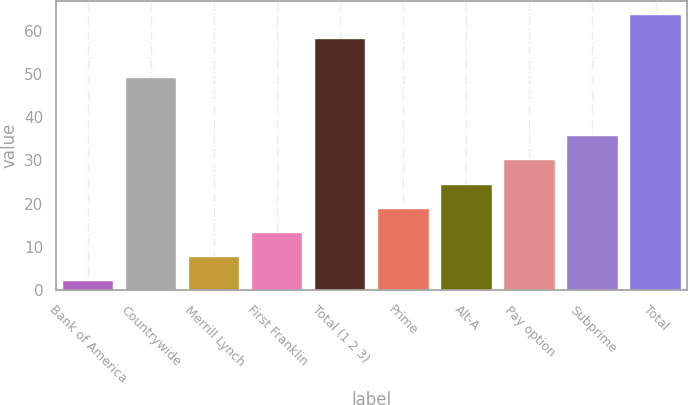<chart> <loc_0><loc_0><loc_500><loc_500><bar_chart><fcel>Bank of America<fcel>Countrywide<fcel>Merrill Lynch<fcel>First Franklin<fcel>Total (1 2 3)<fcel>Prime<fcel>Alt-A<fcel>Pay option<fcel>Subprime<fcel>Total<nl><fcel>2<fcel>49<fcel>7.6<fcel>13.2<fcel>58<fcel>18.8<fcel>24.4<fcel>30<fcel>35.6<fcel>63.6<nl></chart> 